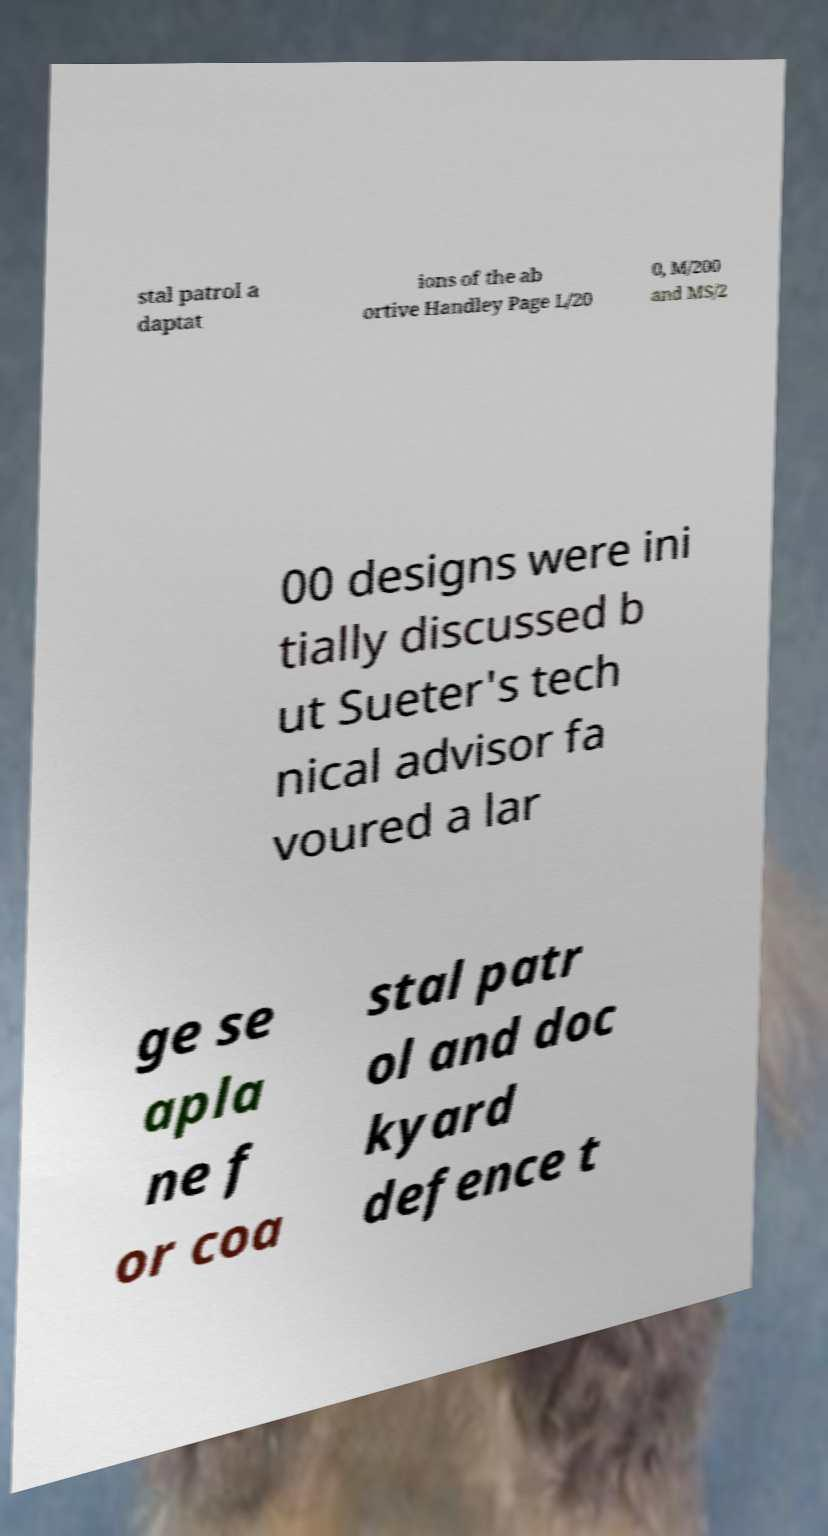Can you accurately transcribe the text from the provided image for me? stal patrol a daptat ions of the ab ortive Handley Page L/20 0, M/200 and MS/2 00 designs were ini tially discussed b ut Sueter's tech nical advisor fa voured a lar ge se apla ne f or coa stal patr ol and doc kyard defence t 